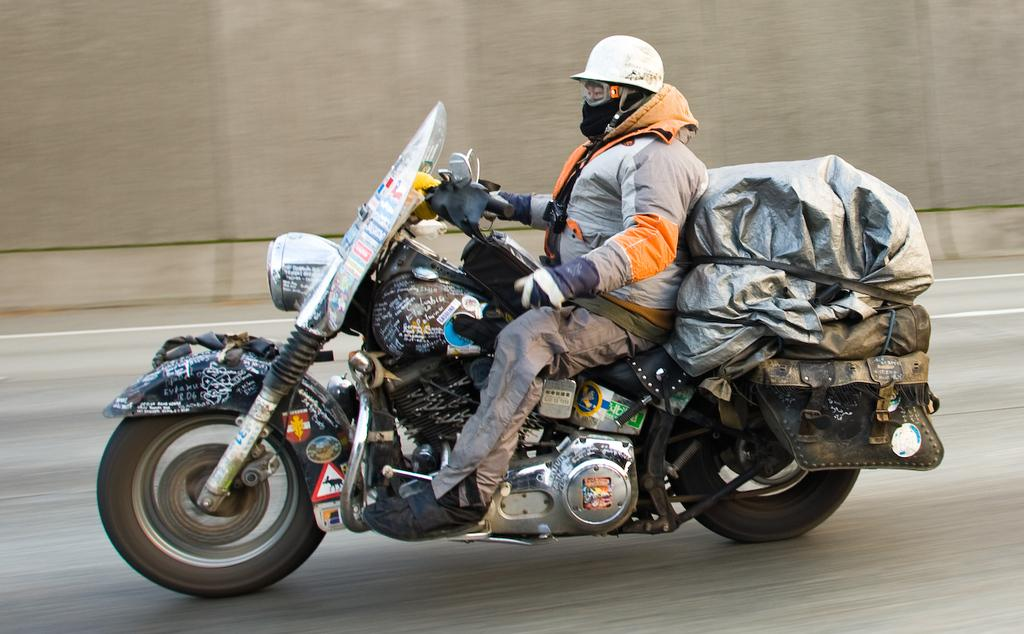Who is the person in the image? There is a man in the image. What is the man doing in the image? The man is riding a bike in the image. What can be seen on the bike? There are items on the bike. Where is the man riding the bike? The man is riding the bike on a road. What type of summer clothing is the man wearing in the image? The provided facts do not mention any specific clothing or the season, so we cannot determine if the man is wearing summer clothing. 